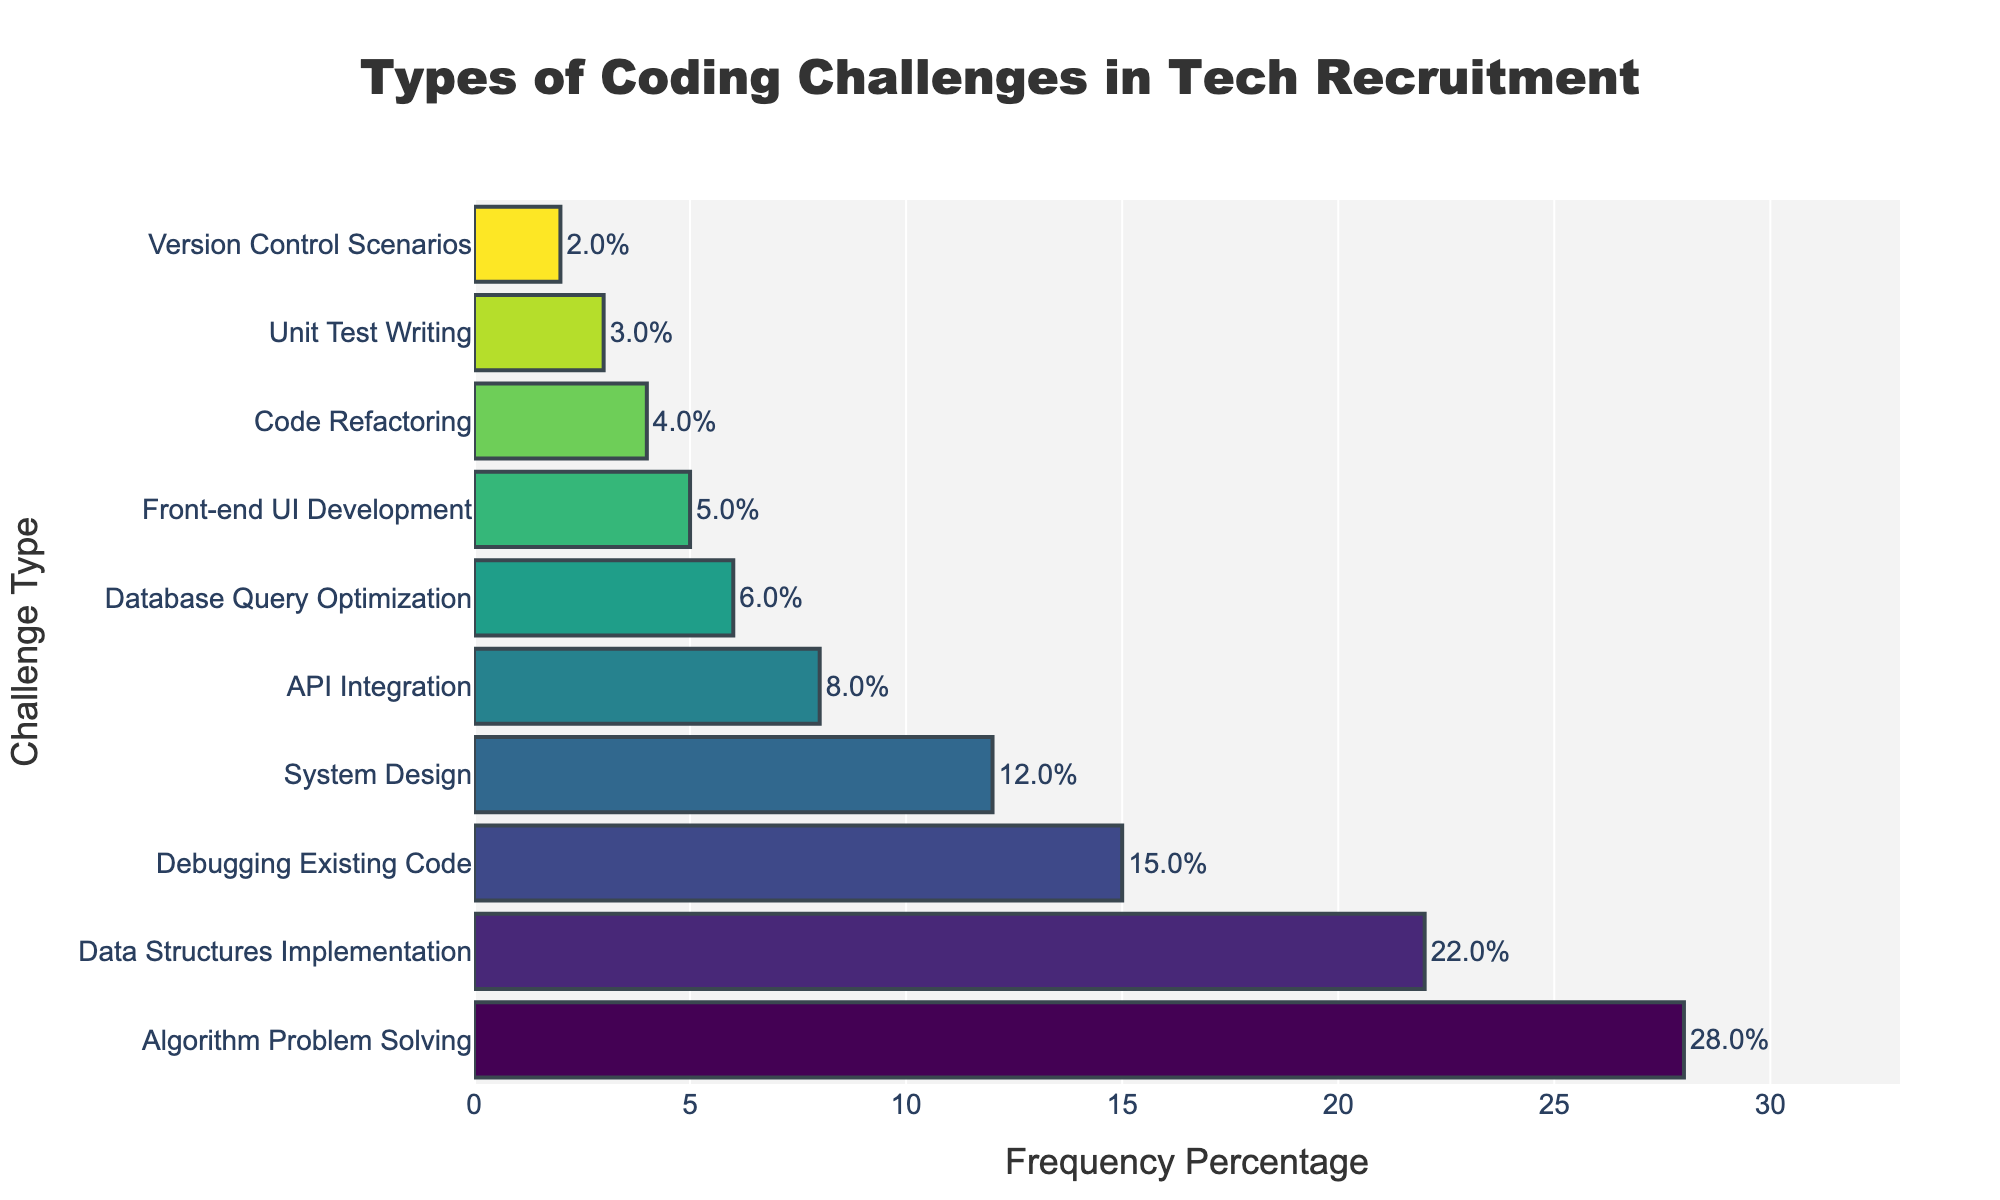Which challenge type is used most frequently in tech recruitment processes? The bar for "Algorithm Problem Solving" is the longest and its percentage is the highest.
Answer: Algorithm Problem Solving Which challenge type is least used in tech recruitment processes? The bar for "Version Control Scenarios" is the shortest and its percentage is the lowest.
Answer: Version Control Scenarios How much more frequently is Algorithm Problem Solving used compared to Code Refactoring? "Algorithm Problem Solving" has a frequency percentage of 28, and "Code Refactoring" has 4. Subtract 4 from 28 to find the difference.
Answer: 24% Which challenge types have a frequency percentage of less than 10%? By looking at the lengths of the bars, the challenge types with percentages less than 10 are: "API Integration," "Database Query Optimization," "Front-end UI Development," "Code Refactoring," "Unit Test Writing," and "Version Control Scenarios."
Answer: API Integration, Database Query Optimization, Front-end UI Development, Code Refactoring, Unit Test Writing, Version Control Scenarios What is the total percentage for all challenge types used in tech recruitment processes? Sum up all the percentages listed: 28 + 22 + 15 + 12 + 8 + 6 + 5 + 4 + 3 + 2. The total is 105%.
Answer: 105% Which challenge type has a frequency percentage closest to 10%? The frequency percentage closest to 10% is "System Design" with 12%.
Answer: System Design How much more frequently are Data Structures Implementation challenges used compared to Unit Test Writing? "Data Structures Implementation" is 22%, and "Unit Test Writing" is 3%. Subtract 3 from 22 to find the difference.
Answer: 19% Are API Integration challenges more frequently used than Database Query Optimization challenges? The bar for "API Integration" is slightly longer than the bar for "Database Query Optimization," indicating a higher frequency percentage.
Answer: Yes What is the combined frequency percentage of debugging-related challenge types (Debugging Existing Code and Code Refactoring)? Add the percentages of "Debugging Existing Code" (15%) and "Code Refactoring" (4%). The total is 19%.
Answer: 19% How does the frequency percentage of Front-end UI Development compare to Data Structures Implementation? "Front-end UI Development" has a frequency percentage of 5%, while "Data Structures Implementation" has 22%. Therefore, Data Structures Implementation is higher.
Answer: Data Structures Implementation is higher 